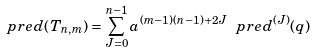<formula> <loc_0><loc_0><loc_500><loc_500>\ p r e d ( T _ { n , m } ) = \sum _ { J = 0 } ^ { n - 1 } a ^ { ( m - 1 ) ( n - 1 ) + 2 J } \ p r e d ^ { ( J ) } ( q )</formula> 